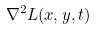Convert formula to latex. <formula><loc_0><loc_0><loc_500><loc_500>\nabla ^ { 2 } L ( x , y , t )</formula> 